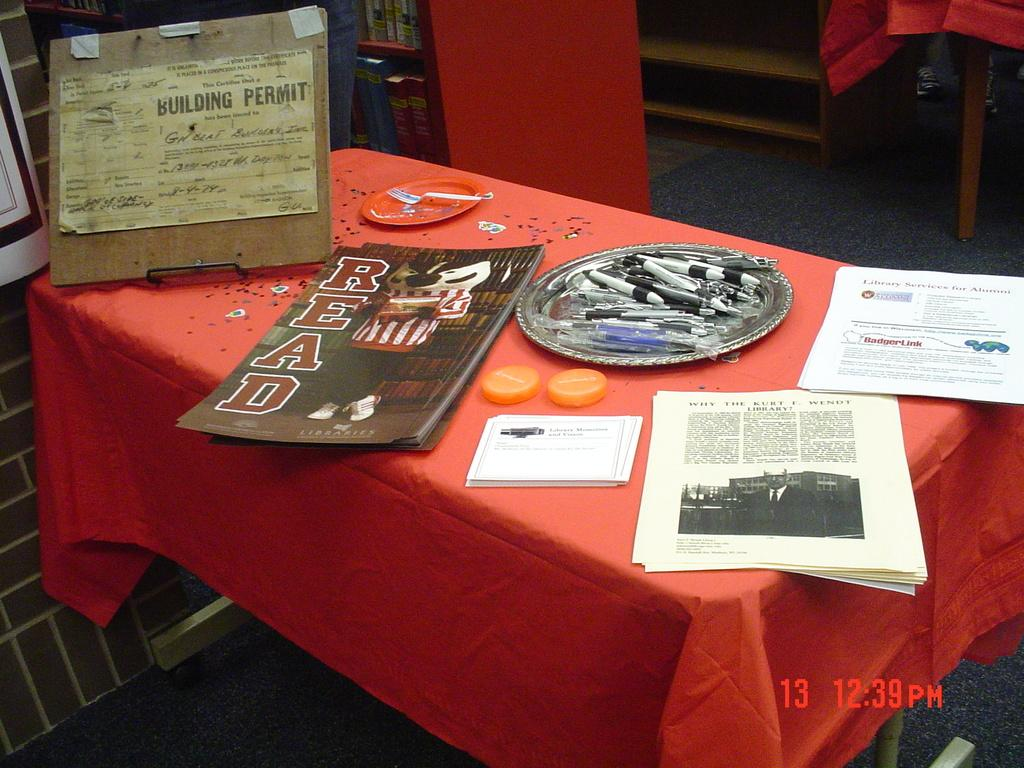<image>
Render a clear and concise summary of the photo. A display table with papers and a magazine has old Building Permit also on displau 